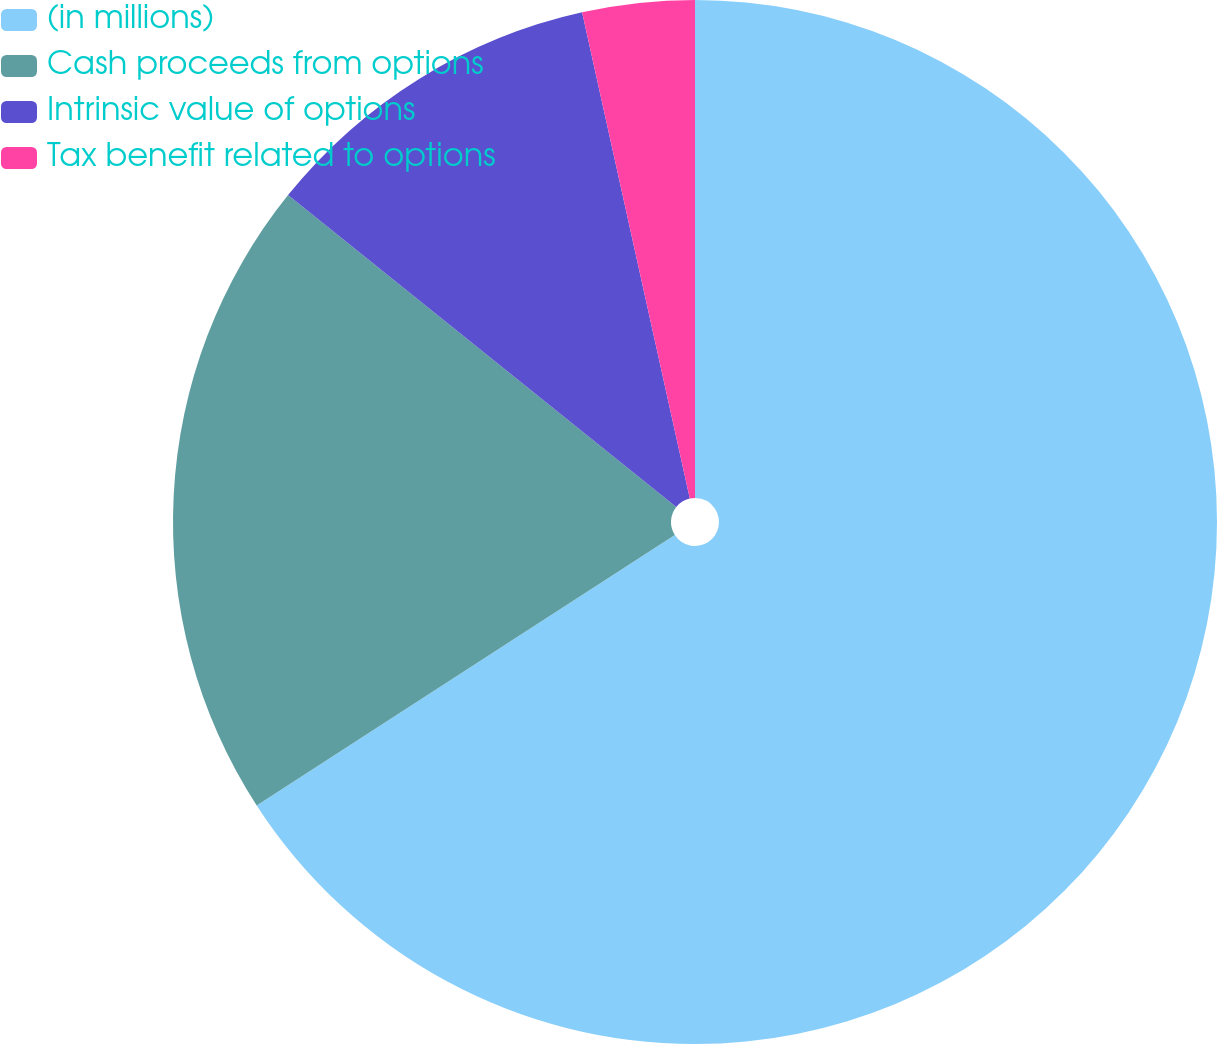Convert chart. <chart><loc_0><loc_0><loc_500><loc_500><pie_chart><fcel>(in millions)<fcel>Cash proceeds from options<fcel>Intrinsic value of options<fcel>Tax benefit related to options<nl><fcel>65.87%<fcel>19.91%<fcel>10.76%<fcel>3.47%<nl></chart> 